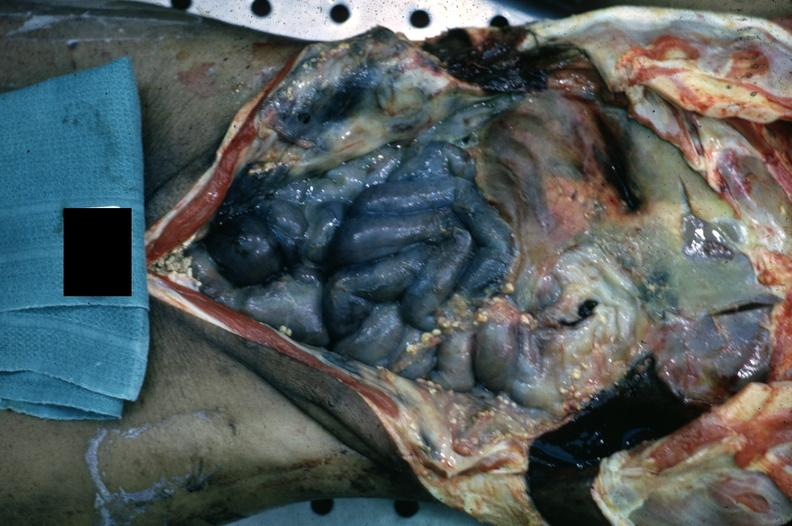what is present?
Answer the question using a single word or phrase. Peritoneum 